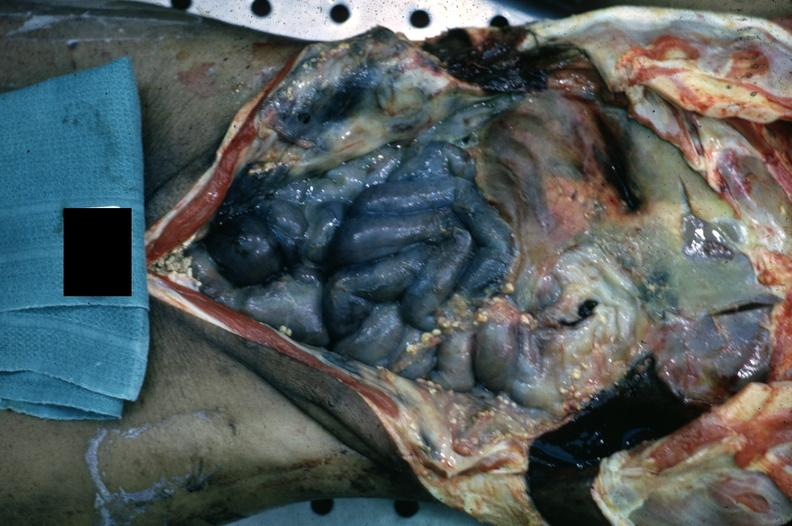what is present?
Answer the question using a single word or phrase. Peritoneum 